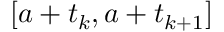Convert formula to latex. <formula><loc_0><loc_0><loc_500><loc_500>[ a + t _ { k } , a + t _ { k + 1 } ]</formula> 